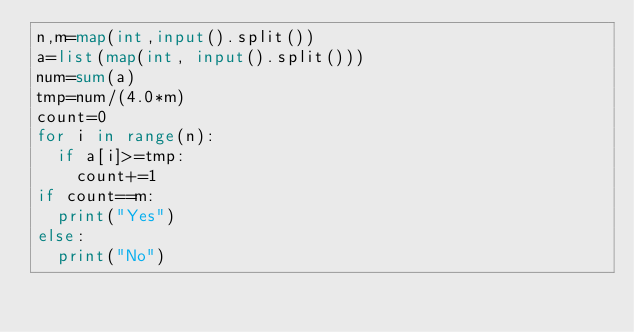Convert code to text. <code><loc_0><loc_0><loc_500><loc_500><_Python_>n,m=map(int,input().split())
a=list(map(int, input().split()))
num=sum(a)
tmp=num/(4.0*m)
count=0
for i in range(n):
  if a[i]>=tmp:
    count+=1
if count==m:
  print("Yes")
else:
  print("No")</code> 